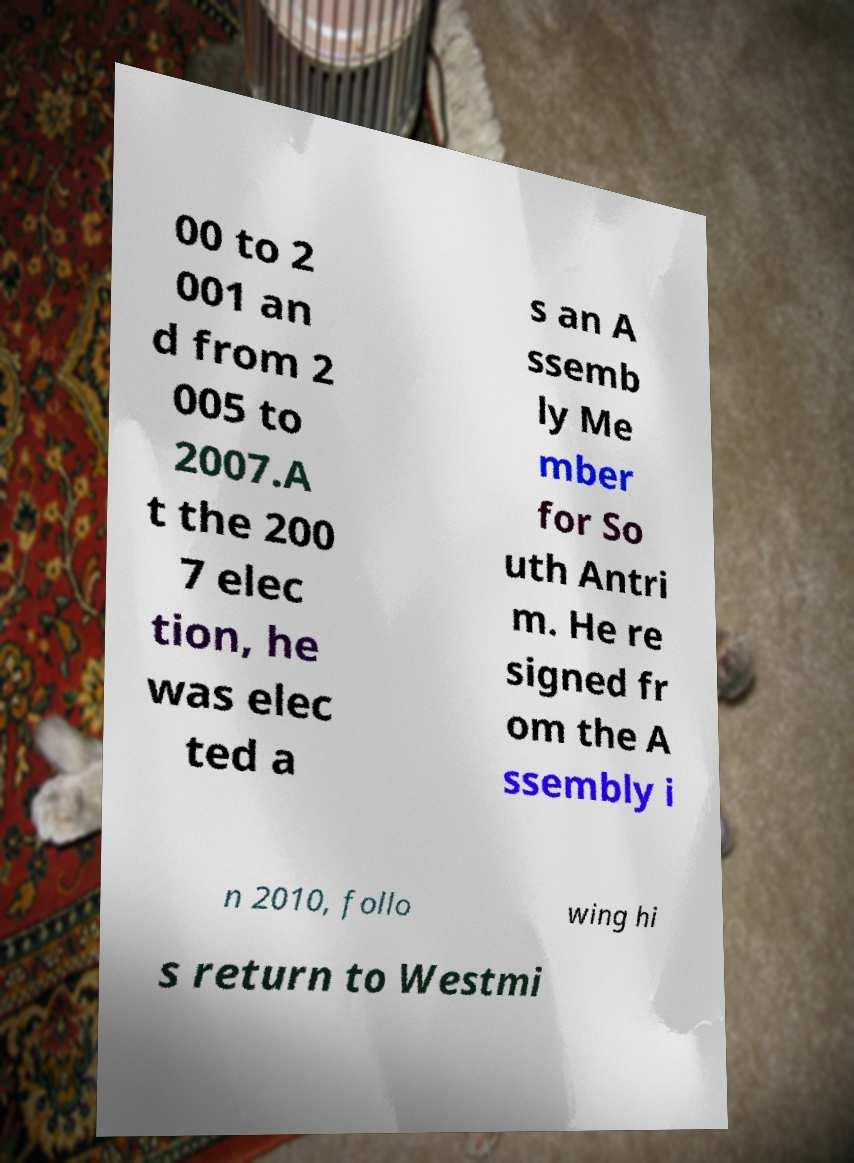Can you accurately transcribe the text from the provided image for me? 00 to 2 001 an d from 2 005 to 2007.A t the 200 7 elec tion, he was elec ted a s an A ssemb ly Me mber for So uth Antri m. He re signed fr om the A ssembly i n 2010, follo wing hi s return to Westmi 